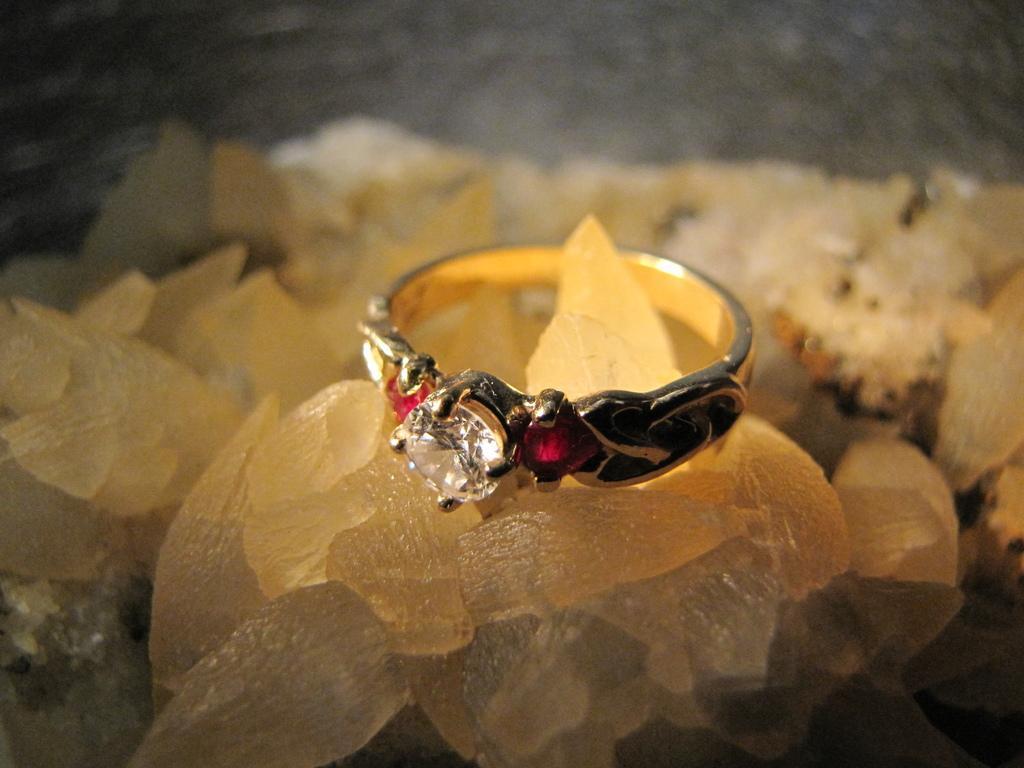Could you give a brief overview of what you see in this image? In this picture, we see a ring which has the white and red stones. At the bottom, it looks like the stones. In the background, it is grey in color. This picture is blurred in the background. 